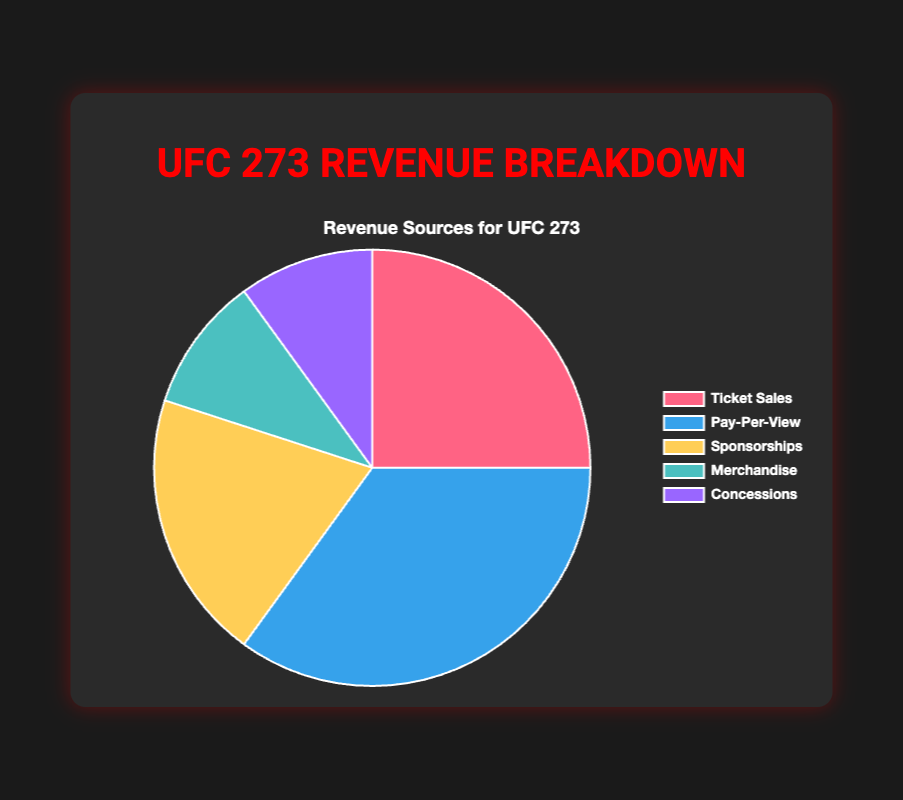What is the largest revenue source for UFC 273? The largest segment in the pie chart represents Pay-Per-View with 35%.
Answer: Pay-Per-View How much combined percentage do Ticket Sales and Merchandise represent? The percentage for Ticket Sales is 25% and for Merchandise is 10%. Adding them together gives 25% + 10% = 35%.
Answer: 35% Which revenue source contributes equally to Merchandise? Both Merchandise and Concessions are represented equally at 10%.
Answer: Concessions If Sponsorships increased by 5%, what would its new percentage be? The current percentage for Sponsorships is 20%. Adding 5% increases it to 20% + 5% = 25%.
Answer: 25% Compare the contribution of Ticket Sales to Sponsorships. Which is larger? Ticket Sales contribute 25%, whereas Sponsorships contribute 20%. Therefore, Ticket Sales is larger.
Answer: Ticket Sales How does the percentage of Pay-Per-View compare to the combined percentage of Merchandise and Concessions? Pay-Per-View is 35%, while Merchandise and Concessions together are 10% + 10% = 20%. 35% is greater than 20%.
Answer: Pay-Per-View is greater Calculate the difference in contribution between Pay-Per-View and Ticket Sales. Pay-Per-View is 35%, and Ticket Sales is 25%. The difference is 35% - 25% = 10%.
Answer: 10% What percentage of revenue is not from Pay-Per-View? The percentage contribution from Pay-Per-View is 35%. The total percentage is 100%, so subtracting Pay-Per-View gives 100% - 35% = 65%.
Answer: 65% Which revenue source is represented in blue? In the chart, the segment corresponding to Pay-Per-View is blue.
Answer: Pay-Per-View How does the Sponsorships' percentage compare to the combined percentage of Ticket Sales and Merchandising? Sponsorships contribute 20%. Ticket Sales and Merchandise together contribute 25% + 10% = 35%. Therefore, 20% is less than 35%.
Answer: Less than 